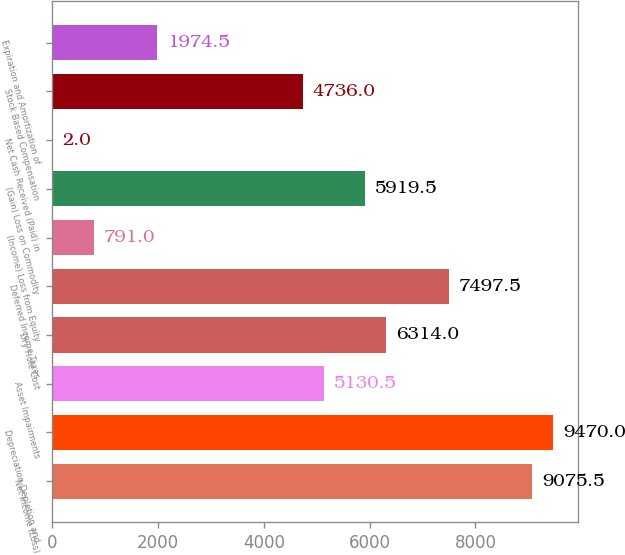<chart> <loc_0><loc_0><loc_500><loc_500><bar_chart><fcel>Net Income (Loss)<fcel>Depreciation Depletion and<fcel>Asset Impairments<fcel>Dry Hole Cost<fcel>Deferred Income Taxes<fcel>(Income) Loss from Equity<fcel>(Gain) Loss on Commodity<fcel>Net Cash Received (Paid) in<fcel>Stock Based Compensation<fcel>Expiration and Amortization of<nl><fcel>9075.5<fcel>9470<fcel>5130.5<fcel>6314<fcel>7497.5<fcel>791<fcel>5919.5<fcel>2<fcel>4736<fcel>1974.5<nl></chart> 